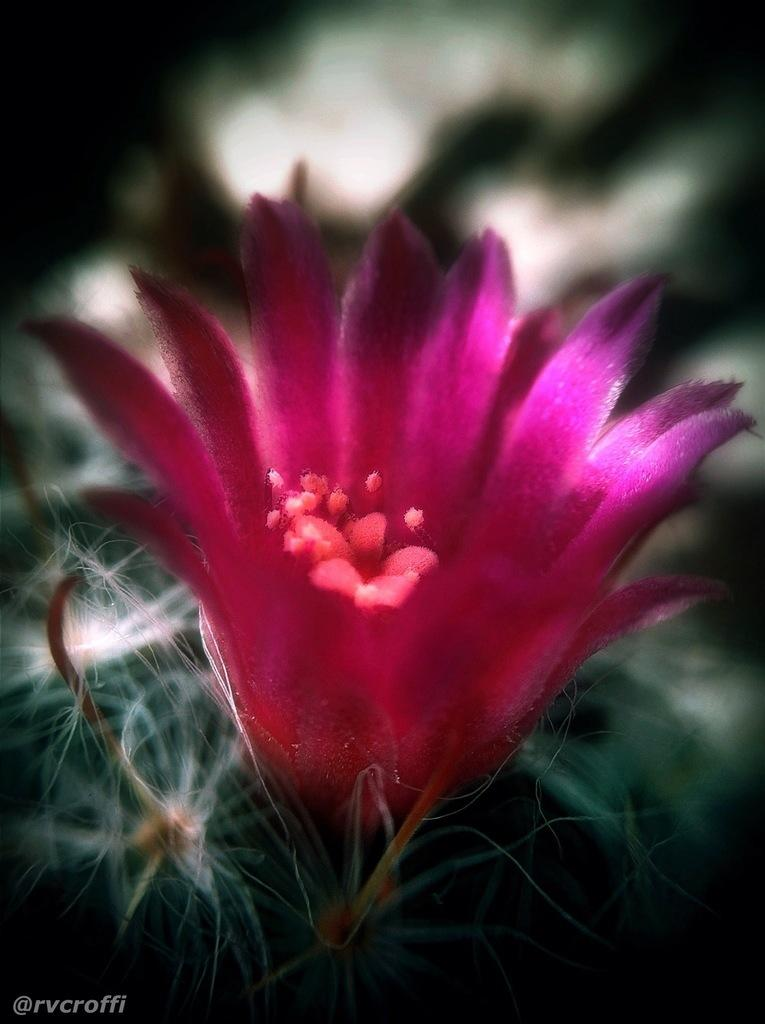What can be observed about the image's appearance? The image is edited. What type of flower is present in the image? There is a pink flower in the image. What color is the background of the flower? The background of the flower is blue. How does the flower attack the viewer in the image? The flower does not attack the viewer in the image; it is a static image of a flower. What part of the body is the flower using to elbow the viewer in the image? The flower does not have a body or the ability to elbow, as it is a non-living object in the image. 